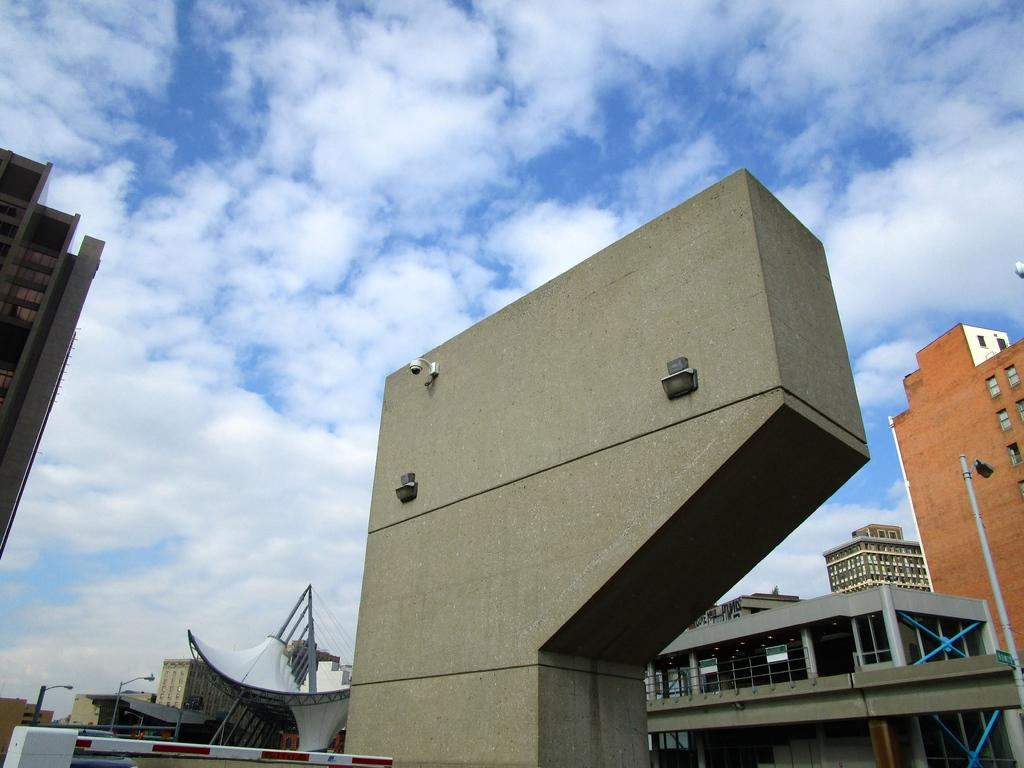What type of structures are present in the image? There are many buildings in the image. What feature can be observed on the buildings? The buildings have multiple windows. What can be seen in the background of the image? There is a sky visible in the image. What type of lighting is present in the image? There are street lights in the image. How many letters can be seen on the scissors in the image? There are no scissors present in the image, so it is not possible to determine how many letters might be on them. 